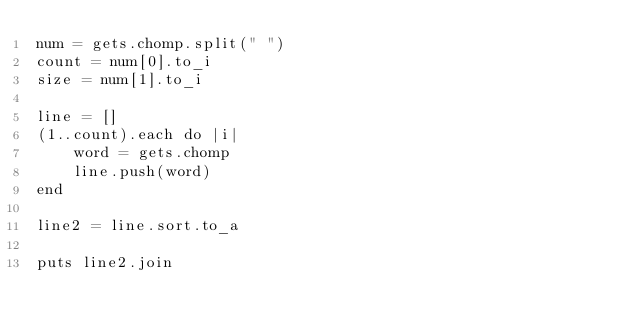Convert code to text. <code><loc_0><loc_0><loc_500><loc_500><_Ruby_>num = gets.chomp.split(" ")
count = num[0].to_i
size = num[1].to_i

line = []
(1..count).each do |i|
    word = gets.chomp
    line.push(word)
end

line2 = line.sort.to_a

puts line2.join</code> 